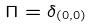Convert formula to latex. <formula><loc_0><loc_0><loc_500><loc_500>\Pi = \delta _ { ( 0 , 0 ) }</formula> 